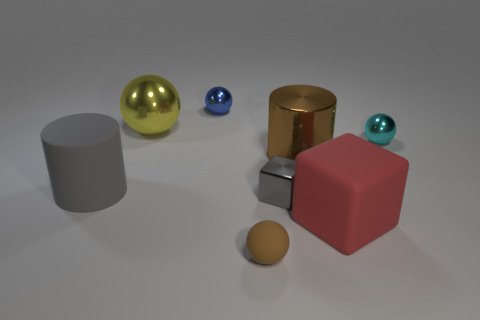Subtract all big yellow spheres. How many spheres are left? 3 Add 1 brown spheres. How many objects exist? 9 Subtract all cylinders. How many objects are left? 6 Add 8 large matte cylinders. How many large matte cylinders are left? 9 Add 2 yellow metallic balls. How many yellow metallic balls exist? 3 Subtract 0 green cubes. How many objects are left? 8 Subtract all large gray matte objects. Subtract all big red things. How many objects are left? 6 